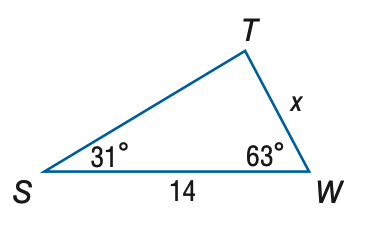Question: Find x. Round to the nearest tenth.
Choices:
A. 7.2
B. 8.1
C. 24.2
D. 27.1
Answer with the letter. Answer: A 